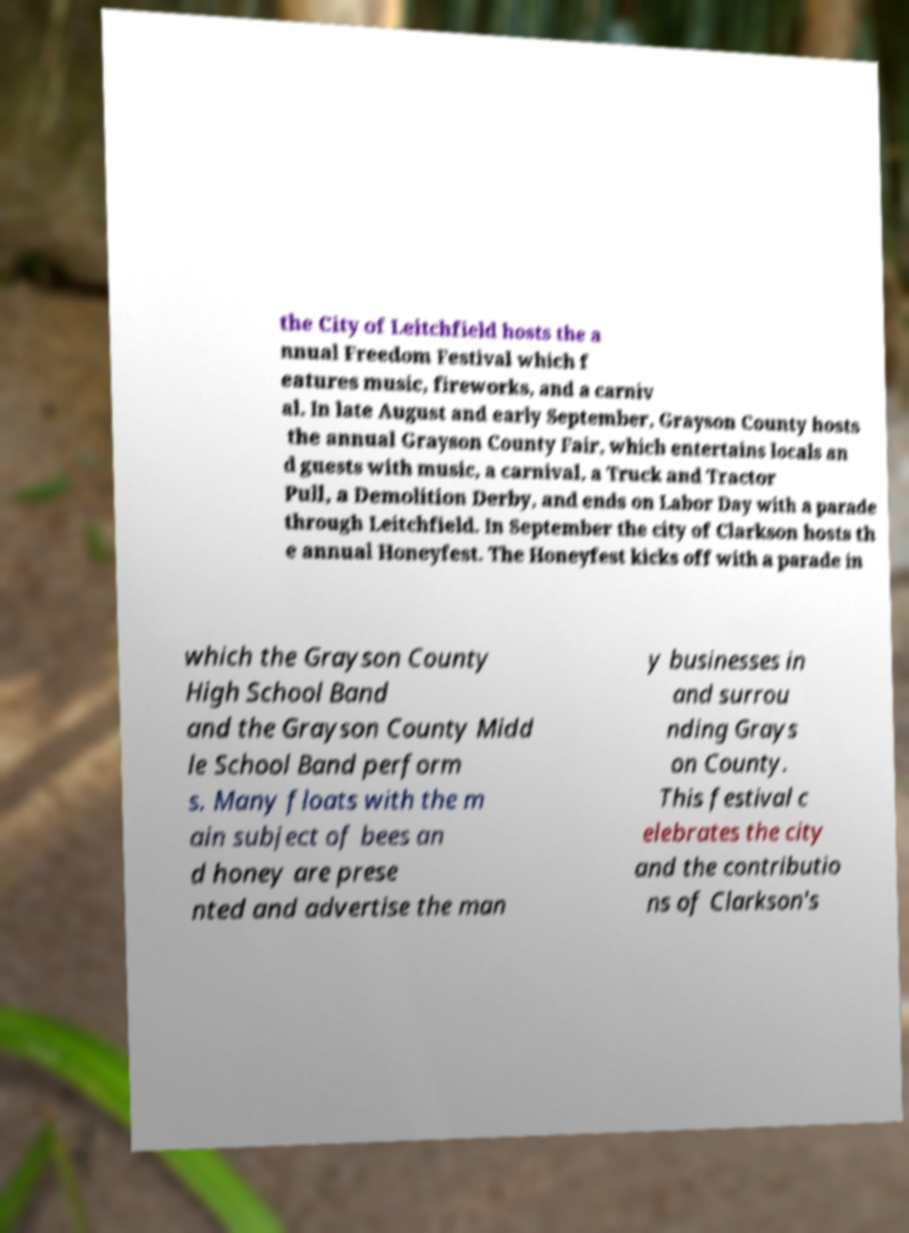What messages or text are displayed in this image? I need them in a readable, typed format. the City of Leitchfield hosts the a nnual Freedom Festival which f eatures music, fireworks, and a carniv al. In late August and early September, Grayson County hosts the annual Grayson County Fair, which entertains locals an d guests with music, a carnival, a Truck and Tractor Pull, a Demolition Derby, and ends on Labor Day with a parade through Leitchfield. In September the city of Clarkson hosts th e annual Honeyfest. The Honeyfest kicks off with a parade in which the Grayson County High School Band and the Grayson County Midd le School Band perform s. Many floats with the m ain subject of bees an d honey are prese nted and advertise the man y businesses in and surrou nding Grays on County. This festival c elebrates the city and the contributio ns of Clarkson's 